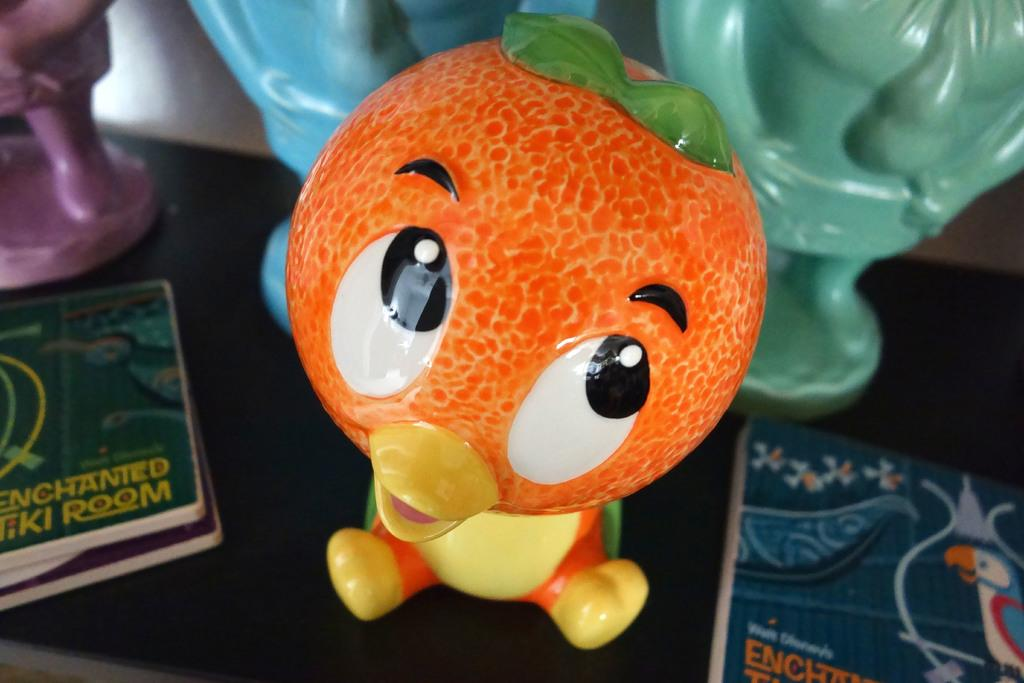What types of items can be seen on the surface in the image? There are toys and objects on the surface in the image. What can be seen in the background of the image? There is a white wall in the background of the image. What type of needle is being used to wash the toys in the image? There is no needle or washing activity present in the image; it only shows toys and objects on a surface with a white wall in the background. 